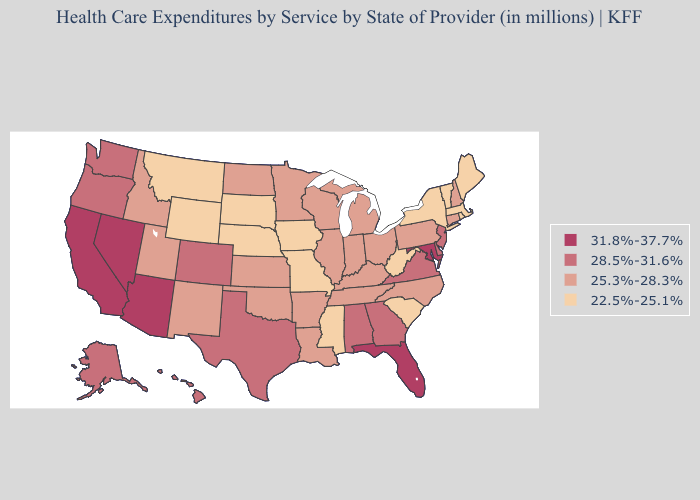Is the legend a continuous bar?
Keep it brief. No. What is the lowest value in the Northeast?
Keep it brief. 22.5%-25.1%. Does Massachusetts have a lower value than New York?
Keep it brief. No. Does Colorado have the lowest value in the USA?
Concise answer only. No. Is the legend a continuous bar?
Keep it brief. No. Is the legend a continuous bar?
Concise answer only. No. Name the states that have a value in the range 25.3%-28.3%?
Be succinct. Arkansas, Connecticut, Idaho, Illinois, Indiana, Kansas, Kentucky, Louisiana, Michigan, Minnesota, New Hampshire, New Mexico, North Carolina, North Dakota, Ohio, Oklahoma, Pennsylvania, Tennessee, Utah, Wisconsin. What is the highest value in the USA?
Give a very brief answer. 31.8%-37.7%. Among the states that border New York , does New Jersey have the highest value?
Answer briefly. Yes. What is the lowest value in the South?
Give a very brief answer. 22.5%-25.1%. Name the states that have a value in the range 31.8%-37.7%?
Keep it brief. Arizona, California, Florida, Maryland, Nevada. Does Wisconsin have a lower value than New York?
Quick response, please. No. How many symbols are there in the legend?
Concise answer only. 4. Name the states that have a value in the range 31.8%-37.7%?
Quick response, please. Arizona, California, Florida, Maryland, Nevada. 